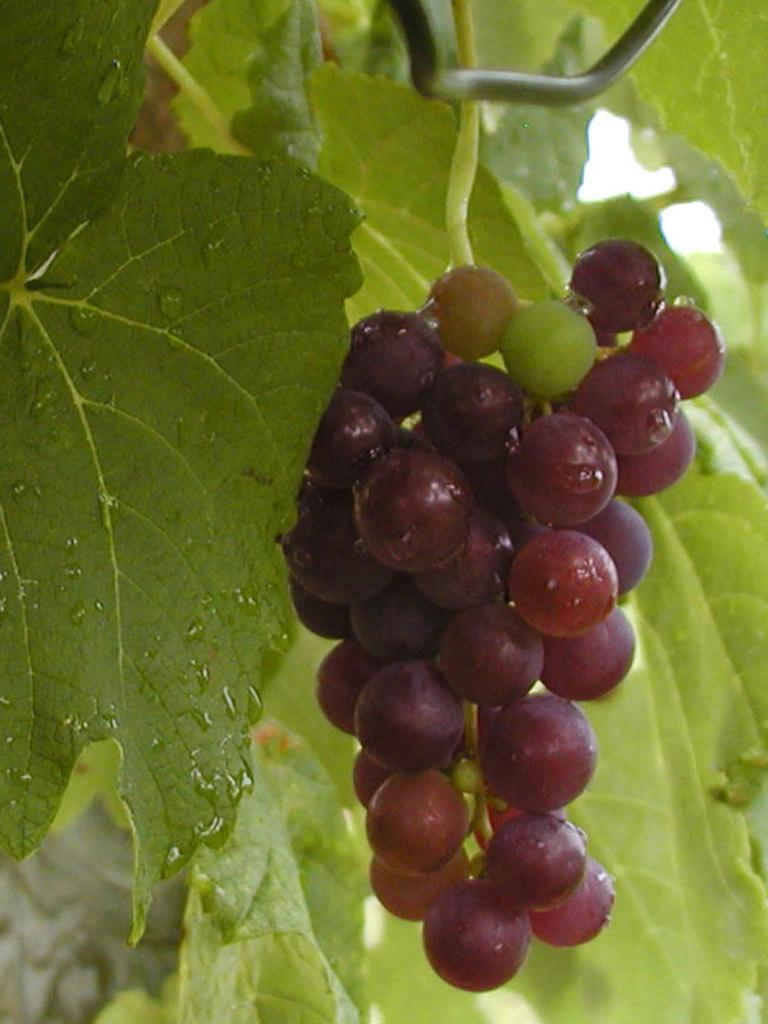What type of fruit is present in the image? There is a bunch of grapes in the image. What else can be seen in the background of the image? There are leaves visible in the background of the image. What type of cloud can be seen in the image? There is no cloud present in the image; it only features a bunch of grapes and leaves in the background. 